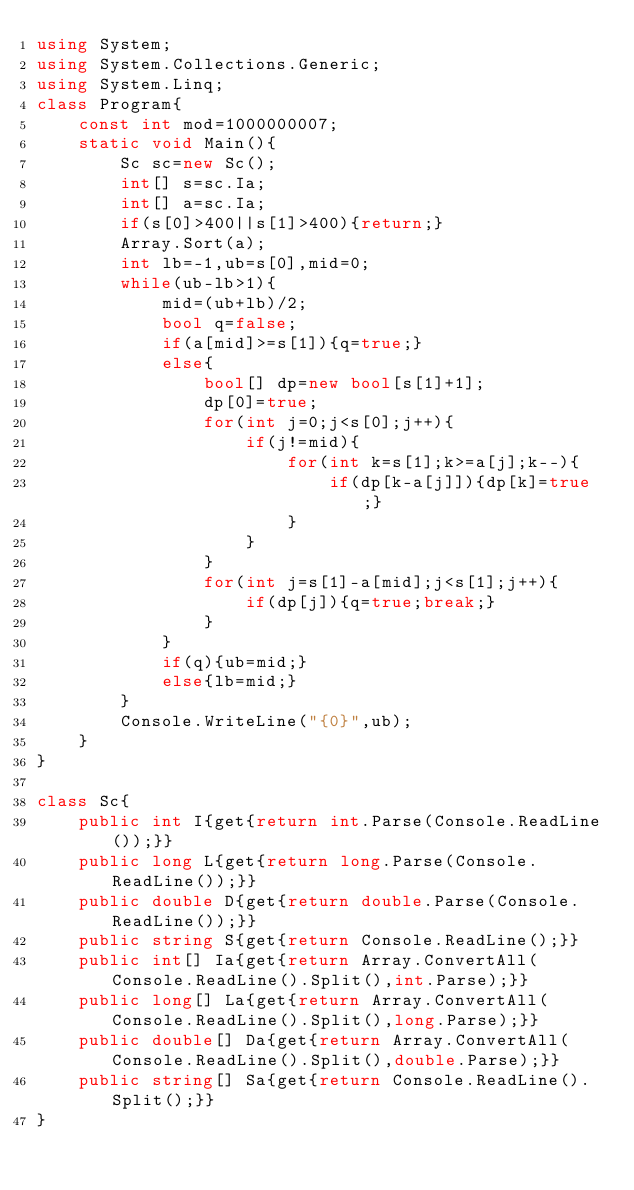Convert code to text. <code><loc_0><loc_0><loc_500><loc_500><_C#_>using System;
using System.Collections.Generic;
using System.Linq;
class Program{
	const int mod=1000000007;
	static void Main(){
		Sc sc=new Sc();
		int[] s=sc.Ia;
		int[] a=sc.Ia;
		if(s[0]>400||s[1]>400){return;}
		Array.Sort(a);
		int lb=-1,ub=s[0],mid=0;
		while(ub-lb>1){
			mid=(ub+lb)/2;
			bool q=false;
			if(a[mid]>=s[1]){q=true;}
			else{
				bool[] dp=new bool[s[1]+1];
				dp[0]=true;
				for(int j=0;j<s[0];j++){
					if(j!=mid){
						for(int k=s[1];k>=a[j];k--){
							if(dp[k-a[j]]){dp[k]=true;}
						}
					}
				}
				for(int j=s[1]-a[mid];j<s[1];j++){
					if(dp[j]){q=true;break;}
				}
			}
			if(q){ub=mid;}
			else{lb=mid;}
		}
		Console.WriteLine("{0}",ub);
	}
}

class Sc{
	public int I{get{return int.Parse(Console.ReadLine());}}
	public long L{get{return long.Parse(Console.ReadLine());}}
	public double D{get{return double.Parse(Console.ReadLine());}}
	public string S{get{return Console.ReadLine();}}
	public int[] Ia{get{return Array.ConvertAll(Console.ReadLine().Split(),int.Parse);}}
	public long[] La{get{return Array.ConvertAll(Console.ReadLine().Split(),long.Parse);}}
	public double[] Da{get{return Array.ConvertAll(Console.ReadLine().Split(),double.Parse);}}
	public string[] Sa{get{return Console.ReadLine().Split();}}
}</code> 